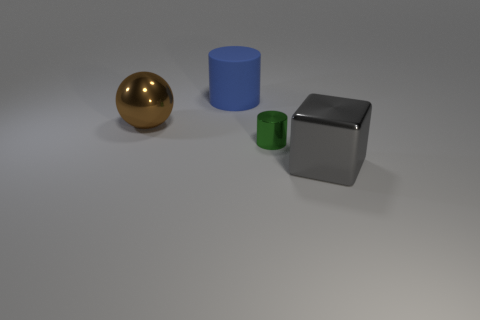Are there any other things that are the same size as the green object?
Offer a very short reply. No. Are there fewer blocks that are right of the block than big gray things?
Your response must be concise. Yes. Is there a big blue sphere that has the same material as the gray cube?
Your response must be concise. No. There is a blue cylinder that is the same size as the brown object; what is its material?
Your answer should be very brief. Rubber. Are there fewer blue rubber things right of the tiny green thing than tiny green things behind the large blue matte cylinder?
Give a very brief answer. No. What shape is the object that is to the right of the big cylinder and to the left of the big gray metal object?
Keep it short and to the point. Cylinder. What number of other things are the same shape as the small metallic object?
Your answer should be compact. 1. There is a cube that is made of the same material as the green cylinder; what is its size?
Offer a terse response. Large. Are there more green metallic objects than tiny cyan balls?
Your answer should be compact. Yes. There is a big metal object that is to the left of the small green metal cylinder; what color is it?
Make the answer very short. Brown. 